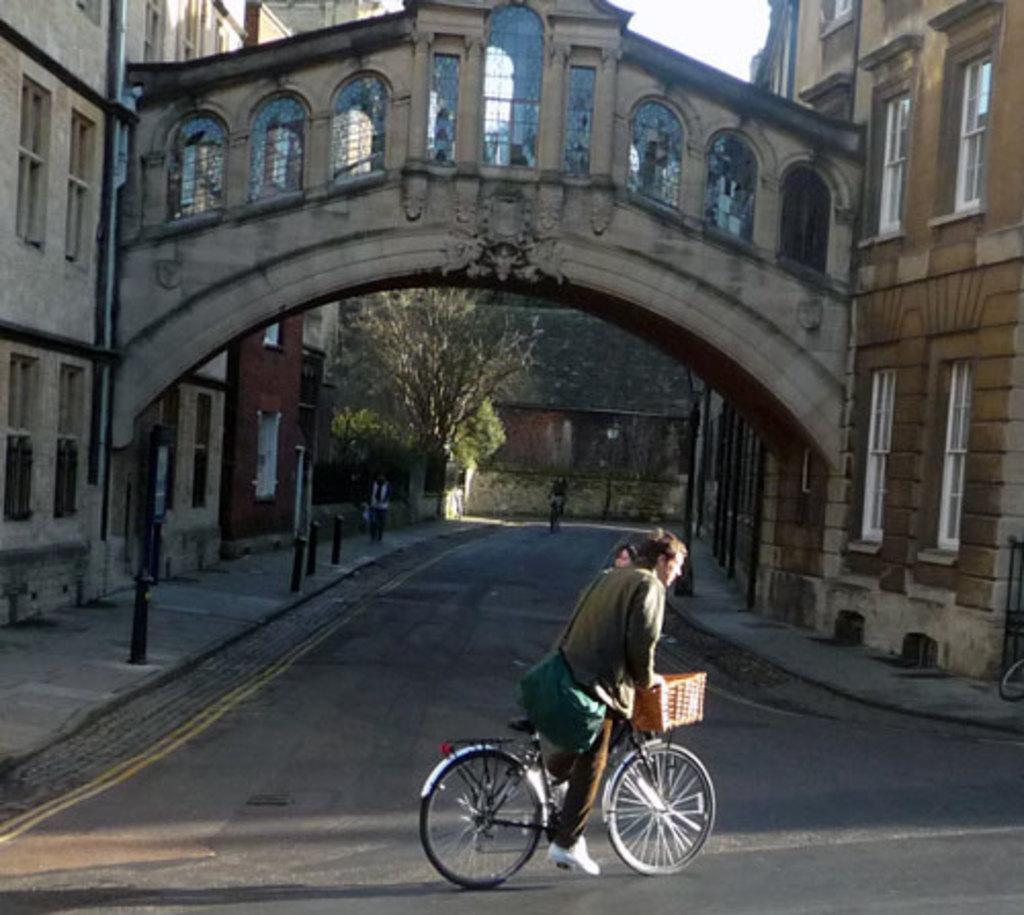In one or two sentences, can you explain what this image depicts? In the center of the image, we can see man riding bicycle and in the background, there are buildings, trees and we can see an other girl riding a bicycle and there are some poles and a man. At the bottom, there is road. 